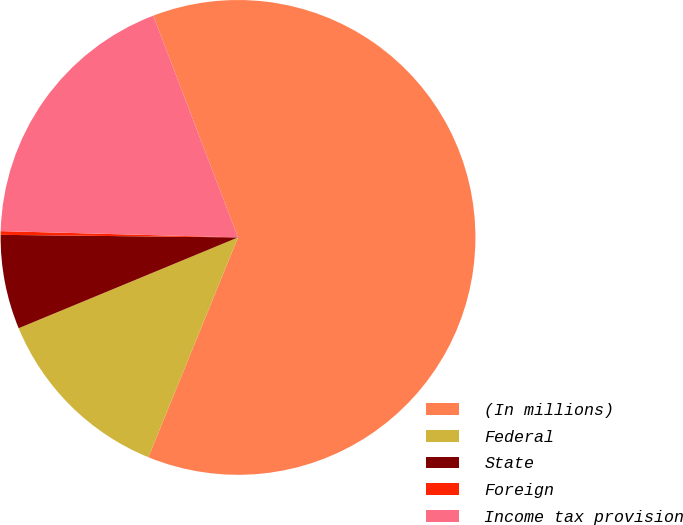<chart> <loc_0><loc_0><loc_500><loc_500><pie_chart><fcel>(In millions)<fcel>Federal<fcel>State<fcel>Foreign<fcel>Income tax provision<nl><fcel>61.98%<fcel>12.59%<fcel>6.42%<fcel>0.25%<fcel>18.77%<nl></chart> 